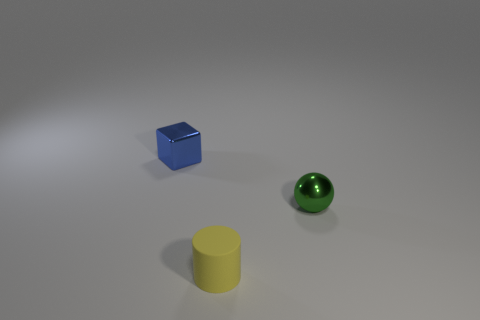Add 1 small blue things. How many objects exist? 4 Subtract all balls. How many objects are left? 2 Subtract 1 cubes. How many cubes are left? 0 Subtract all green cylinders. Subtract all blue blocks. How many cylinders are left? 1 Subtract all big cyan cubes. Subtract all tiny yellow rubber cylinders. How many objects are left? 2 Add 3 small yellow cylinders. How many small yellow cylinders are left? 4 Add 3 green metal things. How many green metal things exist? 4 Subtract 0 green cylinders. How many objects are left? 3 